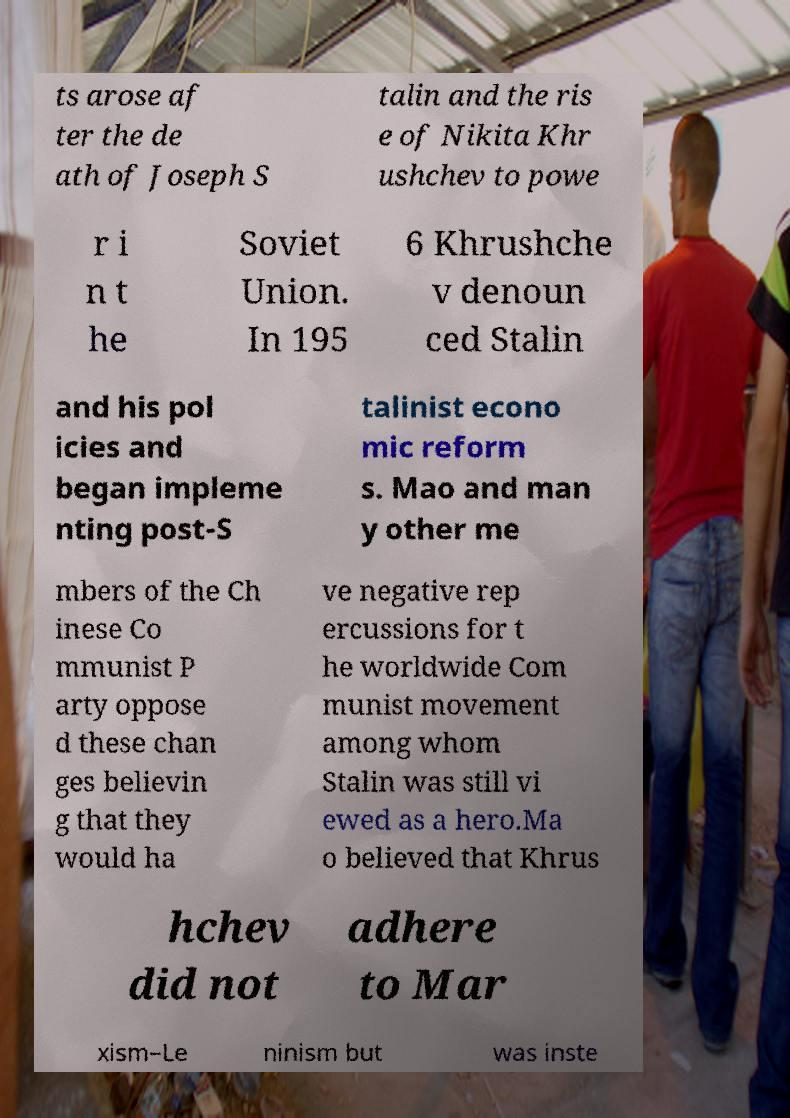What messages or text are displayed in this image? I need them in a readable, typed format. ts arose af ter the de ath of Joseph S talin and the ris e of Nikita Khr ushchev to powe r i n t he Soviet Union. In 195 6 Khrushche v denoun ced Stalin and his pol icies and began impleme nting post-S talinist econo mic reform s. Mao and man y other me mbers of the Ch inese Co mmunist P arty oppose d these chan ges believin g that they would ha ve negative rep ercussions for t he worldwide Com munist movement among whom Stalin was still vi ewed as a hero.Ma o believed that Khrus hchev did not adhere to Mar xism–Le ninism but was inste 